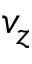Convert formula to latex. <formula><loc_0><loc_0><loc_500><loc_500>v _ { z }</formula> 